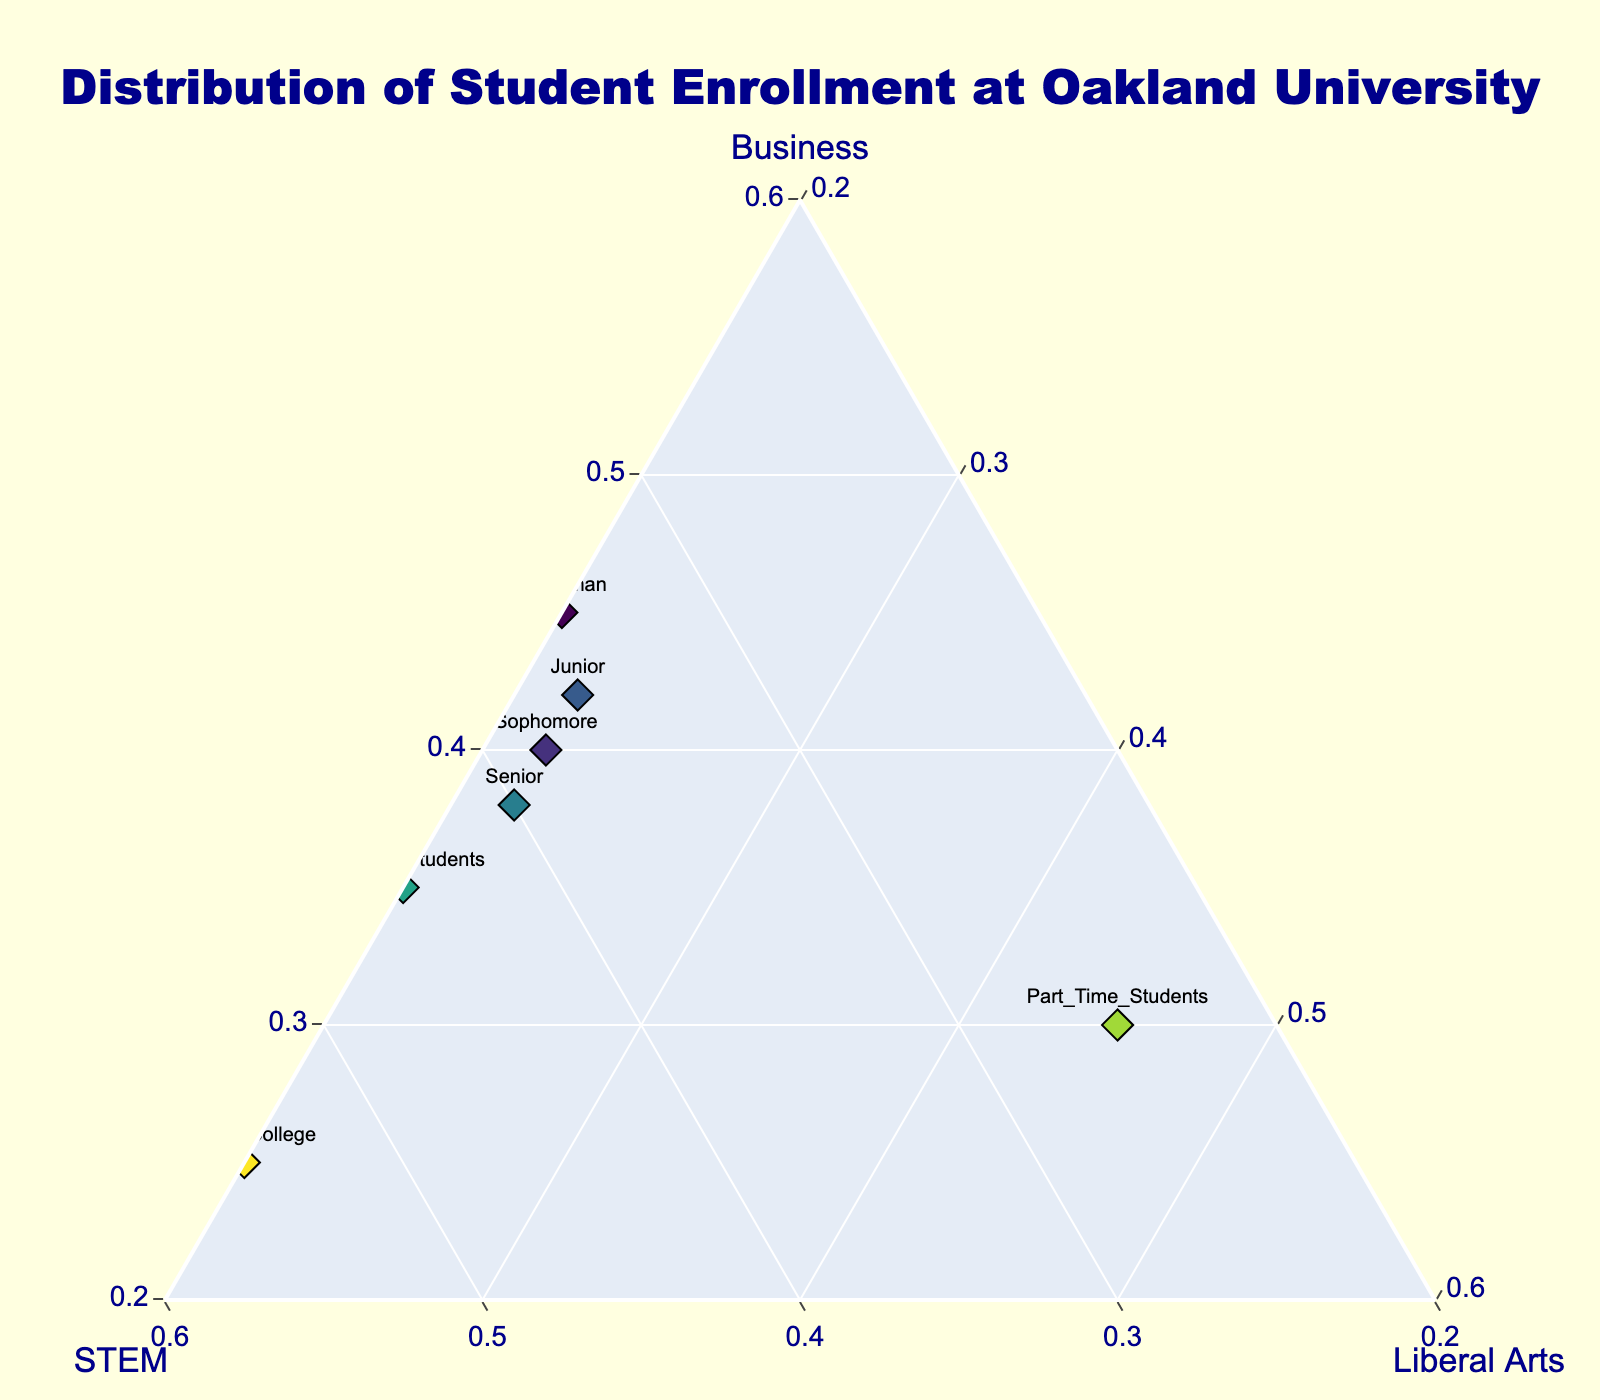What is the title of the figure? The title is located at the top of the figure and is usually the largest text. It describes what the figure is about.
Answer: Distribution of Student Enrollment at Oakland University How many different student categories are represented in the figure? There are different markers, each labeled with a specific student category. Count the different labels to find the answer.
Answer: 8 Which student category has the highest proportion of Business majors? Locate the point where the Business axis is closest to 1 (or the maximum). Check the label associated with that point.
Answer: International Students Which student category has the highest proportion of STEM majors? Locate the point where the STEM axis is closest to 1 (or the maximum). Check the label associated with that point.
Answer: Honors College Which student category has the lowest proportion of Liberal Arts majors? Locate the point where the Liberal Arts axis is closest to 0 (or the minimum). Check the label associated with that point.
Answer: International Students Compare Freshman and Senior students: Which group has a higher proportion of STEM majors? Find the points labeled Freshman and Senior. Compare their positions relative to the STEM axis. The point closer to 1 on this axis represents a higher proportion.
Answer: Senior What is the sum of the proportions of Business and STEM majors for Transfer Students? Locate the point for Transfer Students. Sum the values on the Business and STEM axes for this point.
Answer: 0.8 Among Freshman, Sophomore, and Junior students, which group has the highest proportion of Liberal Arts majors? Compare the points labeled as Freshman, Sophomore, and Junior. Check their positions relative to the Liberal Arts axis. The point closer to 1 on this axis represents a higher proportion.
Answer: Sophomore What is the total number of data points (student categories) shown in the figure? Count all the distinct markers or points labeled in the plot.
Answer: 8 How does the proportion of Business majors among Part-Time Students compare to that of Freshman? Locate the points labeled as Part-Time Students and Freshman. Compare their positions relative to the Business axis. Check which one is closer to 1.
Answer: Freshman 